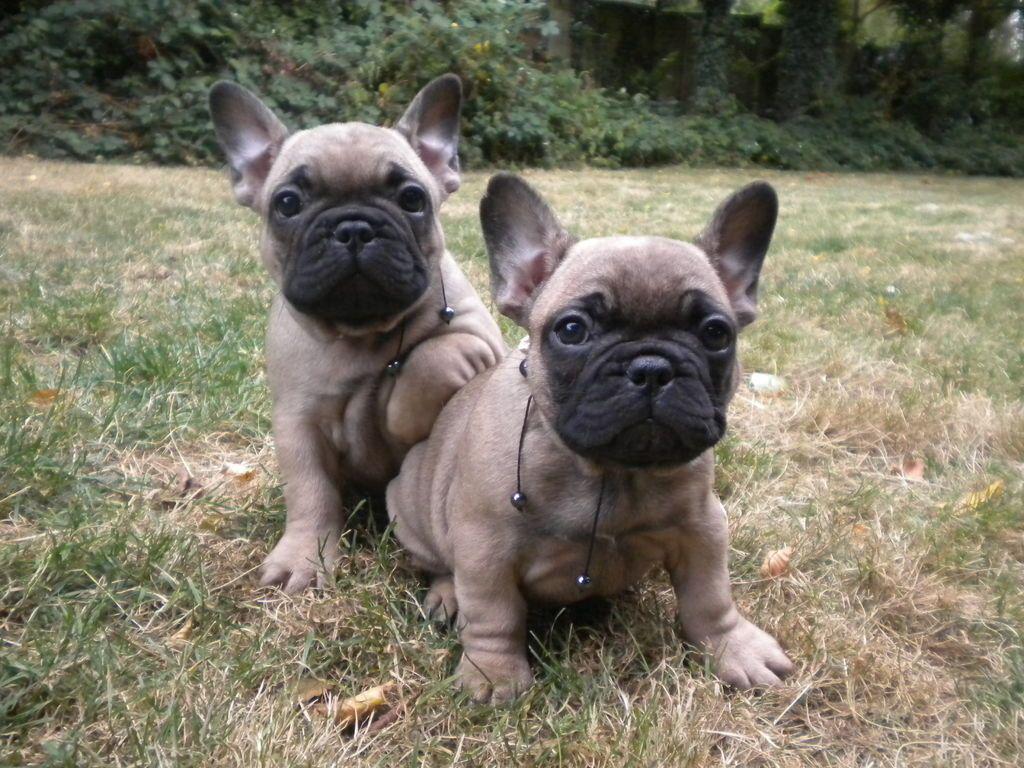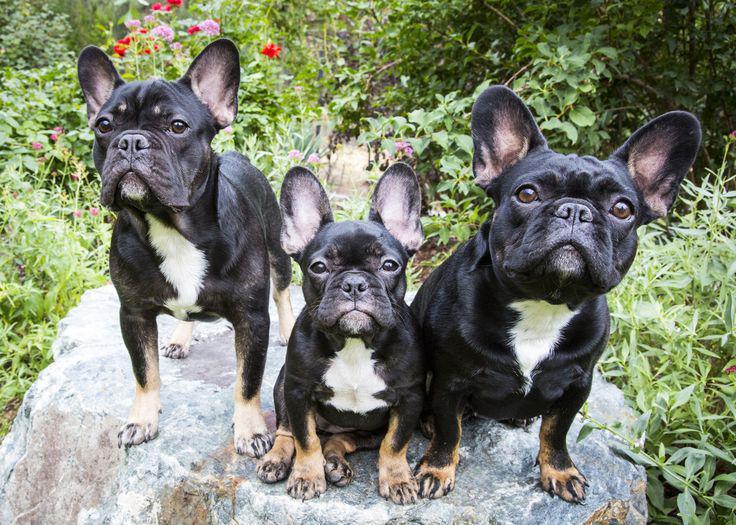The first image is the image on the left, the second image is the image on the right. Analyze the images presented: Is the assertion "The french bulldog in the left image wears a collar and has a black container in front of its chest." valid? Answer yes or no. No. 